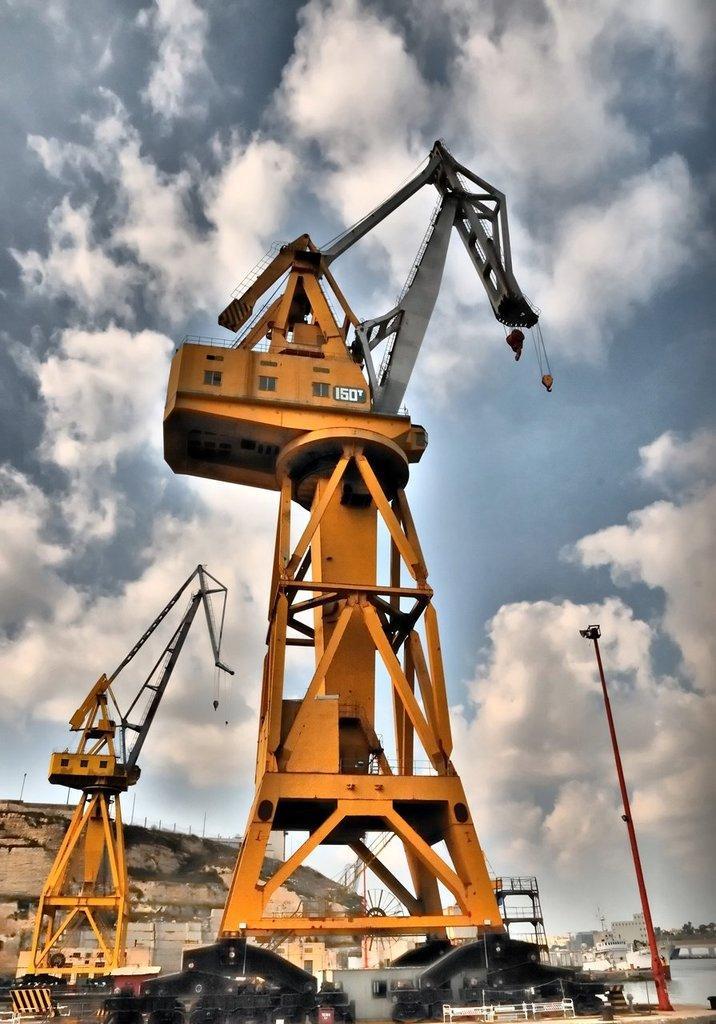In one or two sentences, can you explain what this image depicts? It is a construction area, there are giant cranes and many other equipment around that cranes and in background there is a mountain and beside the mountain there are many houses and there is a tall pole in front of one of the crane. 